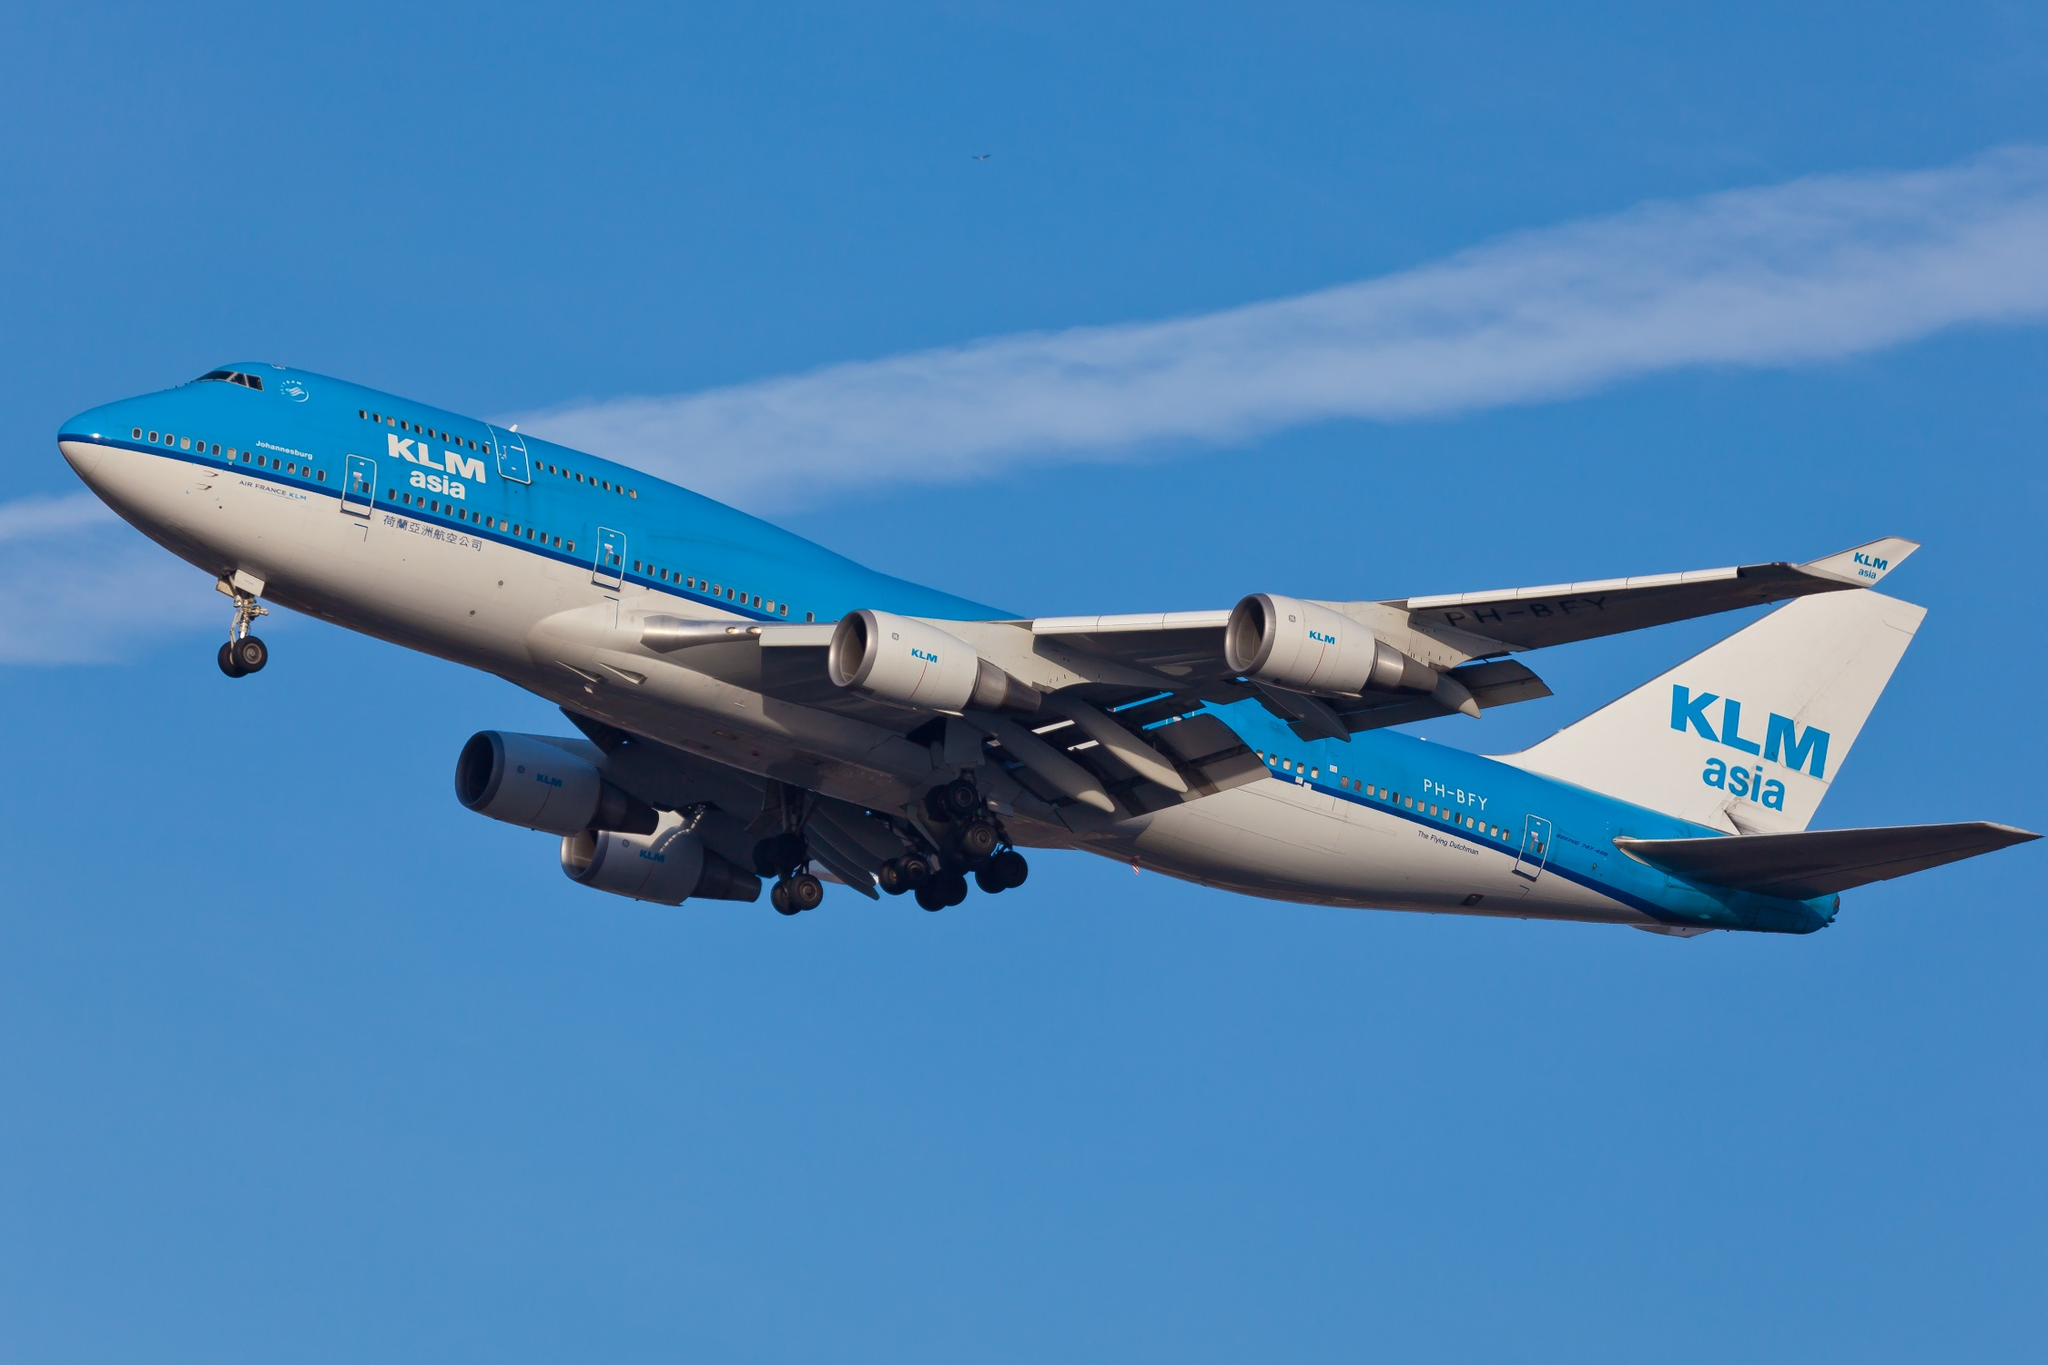Can you discuss the significance of the 'KLM Asia' branding on this aircraft? Certainly! 'KLM Asia' is a subsidiary branding used by KLM Royal Dutch Airlines, designed specifically to operate flights within Asia while adhering to geopolitical sensitivities, particularly concerning Taiwan. This distinct branding strategy, involving the use of a modified livery and registration, ensures compliance with international aviation regulations and local geopolitical nuances. The presence of 'KLM Asia' on the aircraft underscores KLM’s commitment to its Asian routes and the importance of this market in its global operations. 